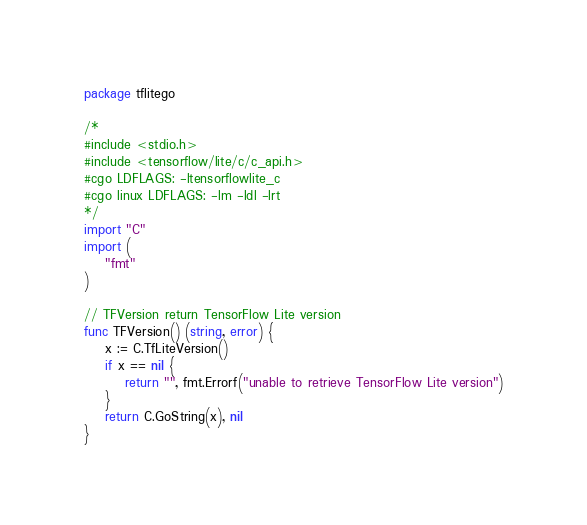Convert code to text. <code><loc_0><loc_0><loc_500><loc_500><_Go_>package tflitego

/*
#include <stdio.h>
#include <tensorflow/lite/c/c_api.h>
#cgo LDFLAGS: -ltensorflowlite_c
#cgo linux LDFLAGS: -lm -ldl -lrt
*/
import "C"
import (
	"fmt"
)

// TFVersion return TensorFlow Lite version
func TFVersion() (string, error) {
	x := C.TfLiteVersion()
	if x == nil {
		return "", fmt.Errorf("unable to retrieve TensorFlow Lite version")
	}
	return C.GoString(x), nil
}</code> 